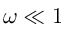<formula> <loc_0><loc_0><loc_500><loc_500>\omega \ll 1</formula> 